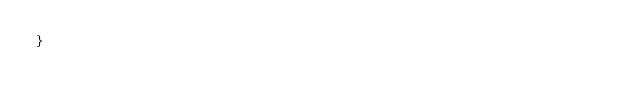<code> <loc_0><loc_0><loc_500><loc_500><_TypeScript_>}
</code> 